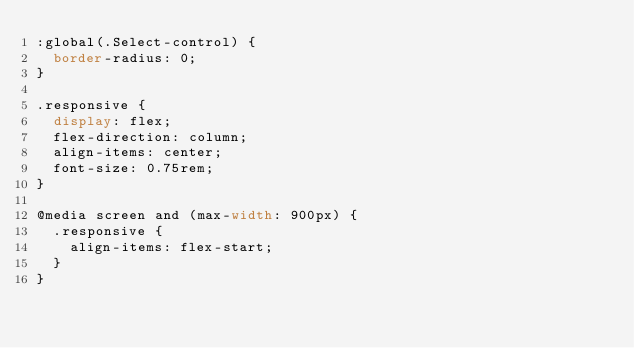<code> <loc_0><loc_0><loc_500><loc_500><_CSS_>:global(.Select-control) {
  border-radius: 0;
}

.responsive {
  display: flex;
  flex-direction: column;
  align-items: center;
  font-size: 0.75rem;
}

@media screen and (max-width: 900px) {
  .responsive {
    align-items: flex-start;
  }
}
</code> 